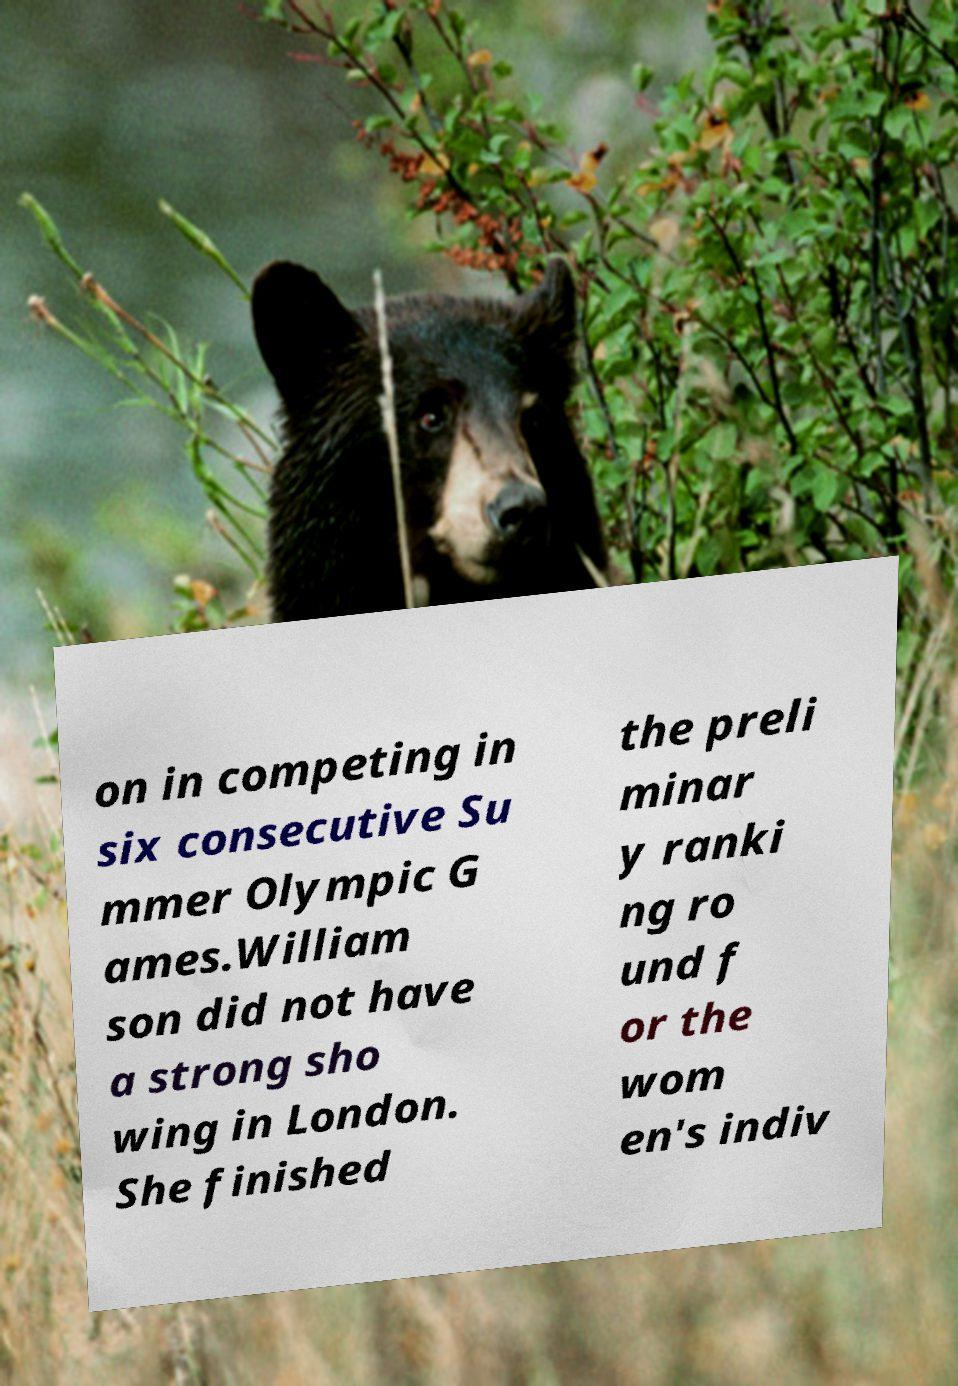I need the written content from this picture converted into text. Can you do that? on in competing in six consecutive Su mmer Olympic G ames.William son did not have a strong sho wing in London. She finished the preli minar y ranki ng ro und f or the wom en's indiv 